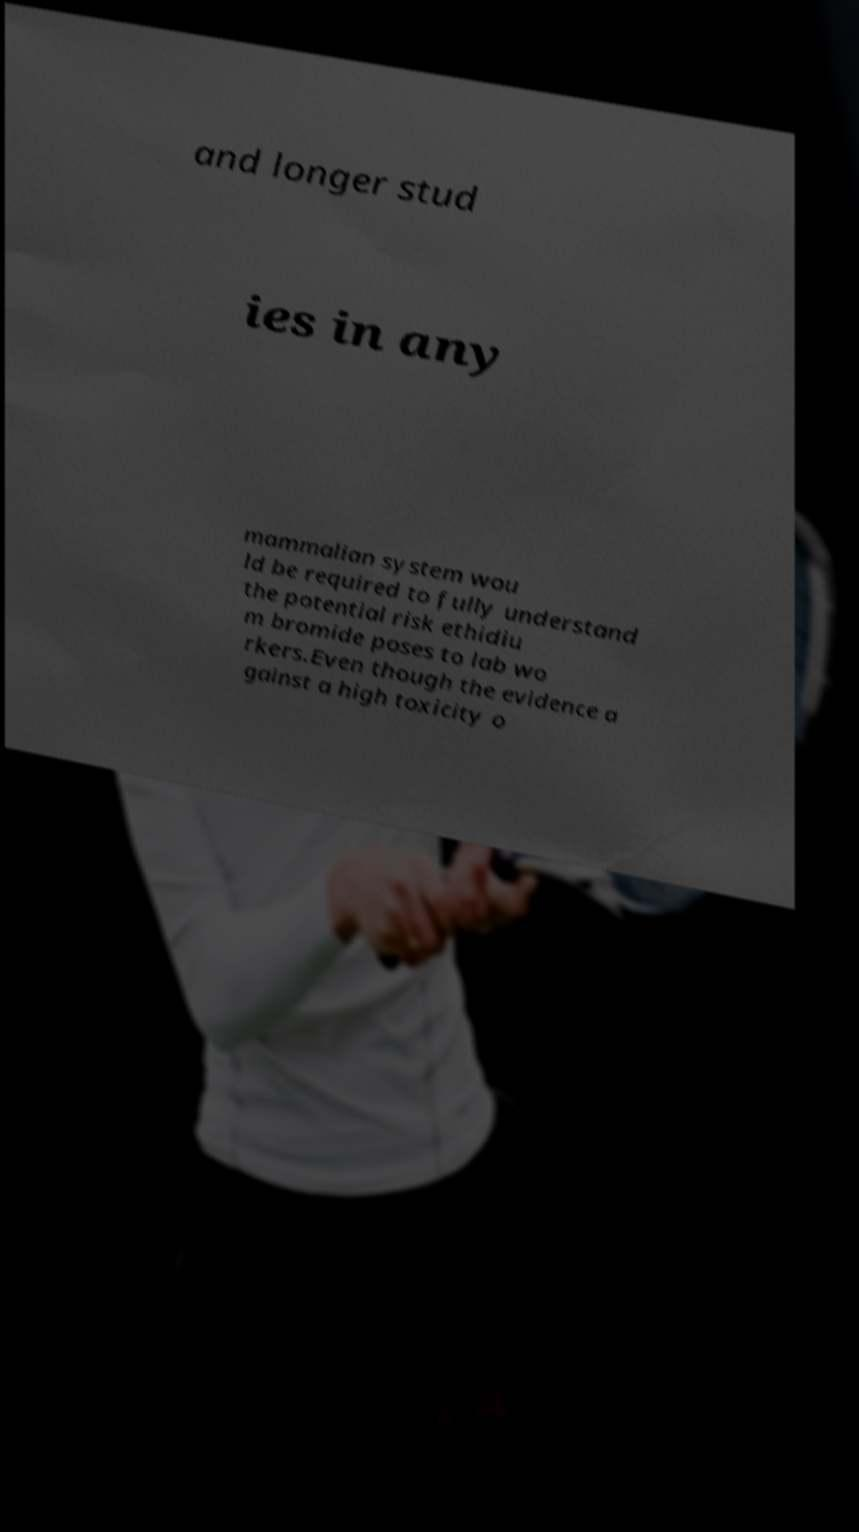Please read and relay the text visible in this image. What does it say? and longer stud ies in any mammalian system wou ld be required to fully understand the potential risk ethidiu m bromide poses to lab wo rkers.Even though the evidence a gainst a high toxicity o 